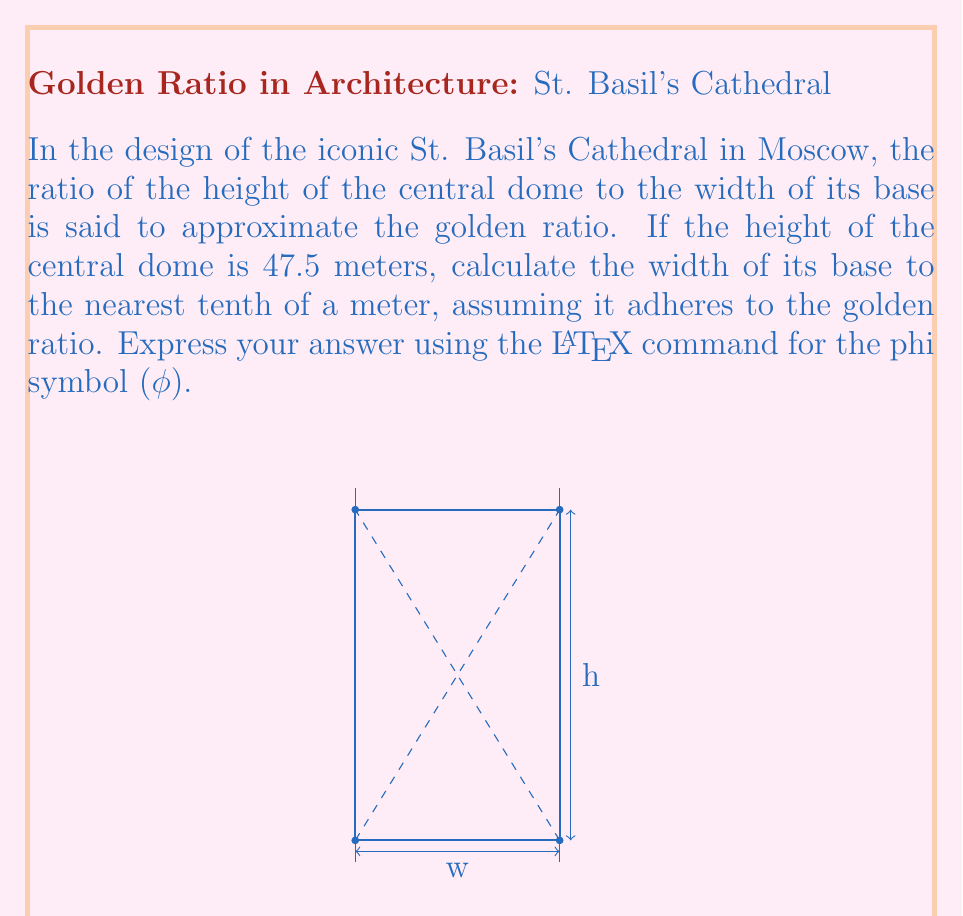Teach me how to tackle this problem. To solve this problem, we'll use the definition of the golden ratio and the given height of the central dome. Let's approach this step-by-step:

1) The golden ratio, denoted by φ (phi), is defined as:

   $$\phi = \frac{1 + \sqrt{5}}{2} \approx 1.618033988749895$$

2) In our case, the ratio of the height (h) to the width (w) should equal φ:

   $$\frac{h}{w} = \phi$$

3) We're given that the height (h) is 47.5 meters. Let's substitute this and φ into our equation:

   $$\frac{47.5}{w} = \phi$$

4) To find w, we need to solve this equation for w:

   $$w = \frac{47.5}{\phi}$$

5) Now, let's substitute the value of φ and calculate:

   $$w = \frac{47.5}{1.618033988749895} \approx 29.3567...$$

6) Rounding to the nearest tenth of a meter as requested:

   $$w \approx 29.4 \text{ meters}$$

Therefore, the width of the base of the central dome, assuming it adheres to the golden ratio, would be approximately 29.4 meters.
Answer: $w \approx 29.4\phi^{-1}$ meters 